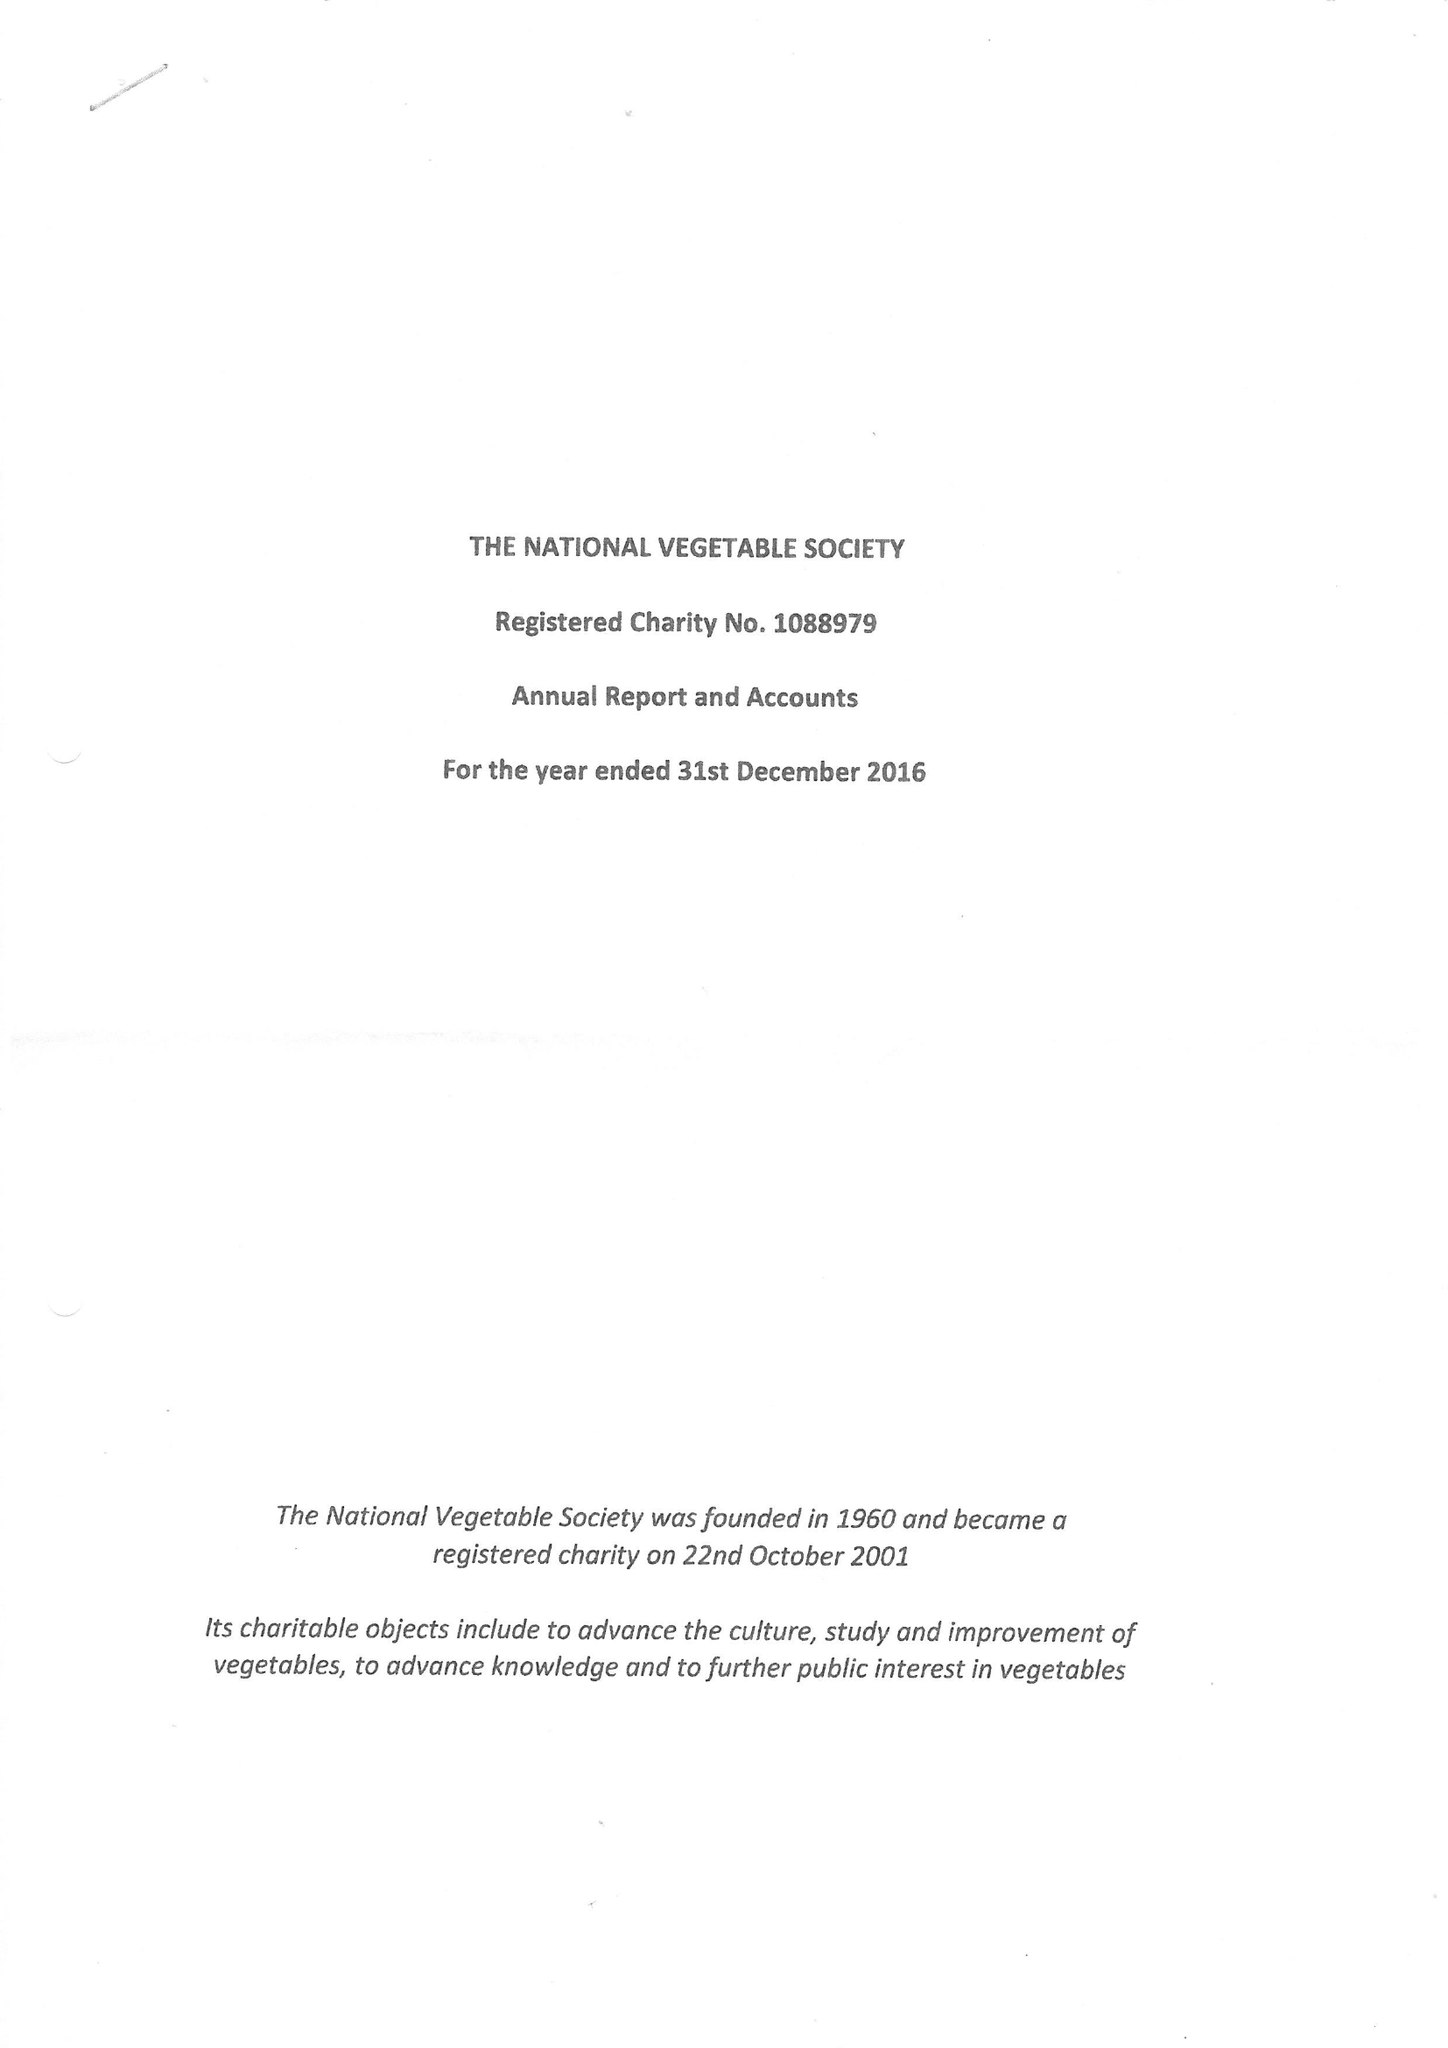What is the value for the address__postcode?
Answer the question using a single word or phrase. KY3 9RH 